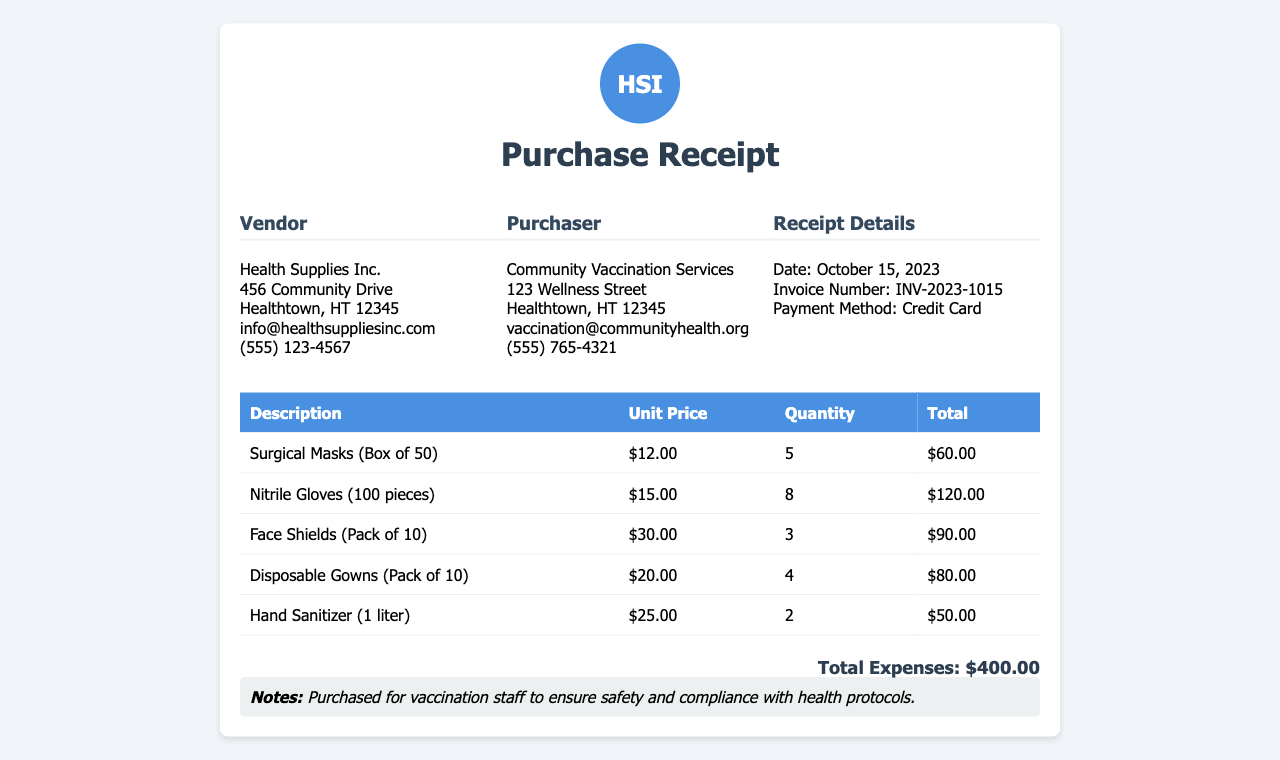what is the date of the purchase? The date of the purchase is indicated in the receipt details section as October 15, 2023.
Answer: October 15, 2023 who is the vendor? The vendor's name is provided in the receipt as Health Supplies Inc.
Answer: Health Supplies Inc how many surgical masks were purchased? The quantity of surgical masks is listed in the table as 5 boxes.
Answer: 5 what was the total cost for nitrile gloves? The total cost for nitrile gloves is calculated as the unit price multiplied by the quantity, which is $15.00 * 8.
Answer: $120.00 what is the total expenses? The total expenses are summarized at the end of the document, stating the total amount spent.
Answer: $400.00 which payment method was used? The payment method section indicates that a credit card was used to pay for the purchases.
Answer: Credit Card what is the item description of the third listed product? The third product's description is given in the table as Face Shields (Pack of 10).
Answer: Face Shields (Pack of 10) how many disposable gowns were purchased? The quantity of disposable gowns is clearly stated in the receipt as 4 packs.
Answer: 4 what is the email address of the vendor? The vendor's contact email is provided in the receipt as info@healthsuppliesinc.com.
Answer: info@healthsuppliesinc.com 